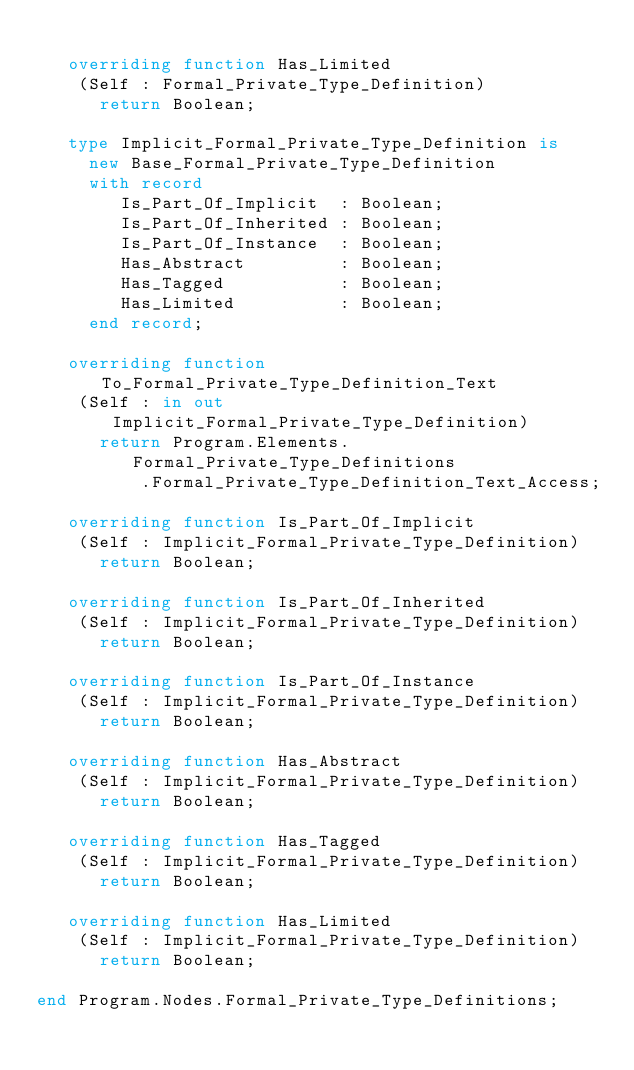<code> <loc_0><loc_0><loc_500><loc_500><_Ada_>
   overriding function Has_Limited
    (Self : Formal_Private_Type_Definition)
      return Boolean;

   type Implicit_Formal_Private_Type_Definition is
     new Base_Formal_Private_Type_Definition
     with record
        Is_Part_Of_Implicit  : Boolean;
        Is_Part_Of_Inherited : Boolean;
        Is_Part_Of_Instance  : Boolean;
        Has_Abstract         : Boolean;
        Has_Tagged           : Boolean;
        Has_Limited          : Boolean;
     end record;

   overriding function To_Formal_Private_Type_Definition_Text
    (Self : in out Implicit_Formal_Private_Type_Definition)
      return Program.Elements.Formal_Private_Type_Definitions
          .Formal_Private_Type_Definition_Text_Access;

   overriding function Is_Part_Of_Implicit
    (Self : Implicit_Formal_Private_Type_Definition)
      return Boolean;

   overriding function Is_Part_Of_Inherited
    (Self : Implicit_Formal_Private_Type_Definition)
      return Boolean;

   overriding function Is_Part_Of_Instance
    (Self : Implicit_Formal_Private_Type_Definition)
      return Boolean;

   overriding function Has_Abstract
    (Self : Implicit_Formal_Private_Type_Definition)
      return Boolean;

   overriding function Has_Tagged
    (Self : Implicit_Formal_Private_Type_Definition)
      return Boolean;

   overriding function Has_Limited
    (Self : Implicit_Formal_Private_Type_Definition)
      return Boolean;

end Program.Nodes.Formal_Private_Type_Definitions;
</code> 